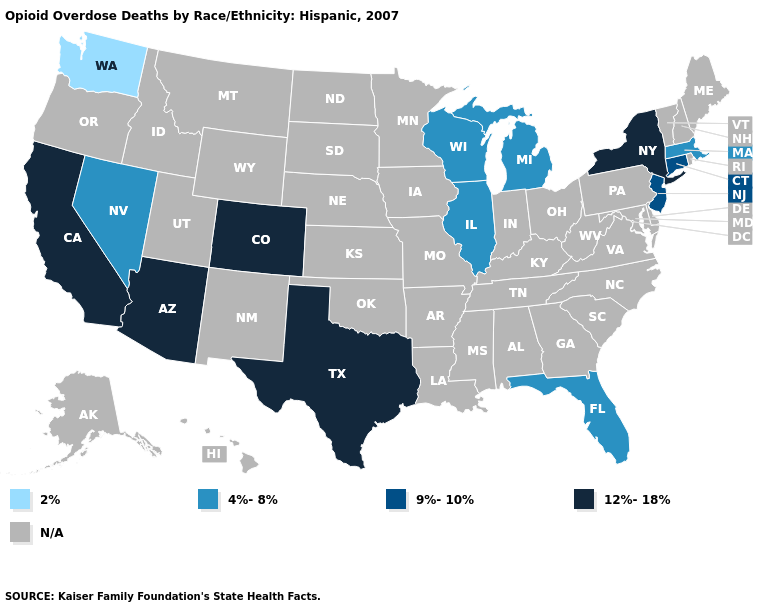Among the states that border Utah , does Arizona have the highest value?
Short answer required. Yes. What is the value of Arizona?
Give a very brief answer. 12%-18%. What is the value of Ohio?
Write a very short answer. N/A. What is the value of Alaska?
Give a very brief answer. N/A. What is the value of North Dakota?
Be succinct. N/A. Name the states that have a value in the range 12%-18%?
Quick response, please. Arizona, California, Colorado, New York, Texas. Which states hav the highest value in the MidWest?
Answer briefly. Illinois, Michigan, Wisconsin. What is the highest value in the MidWest ?
Answer briefly. 4%-8%. What is the value of North Carolina?
Answer briefly. N/A. What is the highest value in states that border New Mexico?
Short answer required. 12%-18%. What is the value of Oregon?
Write a very short answer. N/A. What is the lowest value in the MidWest?
Be succinct. 4%-8%. Does Washington have the lowest value in the USA?
Be succinct. Yes. 